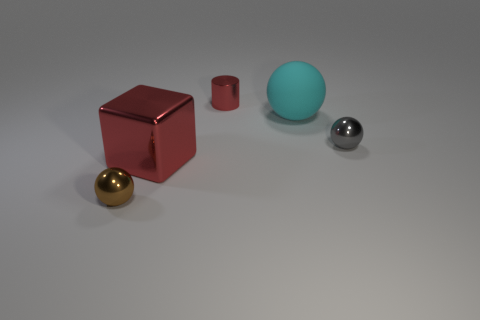Is there any other thing that has the same material as the large ball?
Provide a short and direct response. No. There is a small ball behind the small sphere that is in front of the gray shiny ball; what number of balls are in front of it?
Give a very brief answer. 1. What is the size of the cyan thing that is the same shape as the gray thing?
Keep it short and to the point. Large. Are there fewer small metallic spheres that are on the left side of the large ball than small metal things?
Make the answer very short. Yes. Does the cyan object have the same shape as the tiny red metal thing?
Your answer should be very brief. No. The other tiny object that is the same shape as the tiny gray metallic thing is what color?
Give a very brief answer. Brown. How many small metal cylinders are the same color as the big metal block?
Provide a succinct answer. 1. How many objects are either shiny balls that are on the right side of the small brown ball or tiny gray shiny balls?
Offer a terse response. 1. There is a red thing in front of the matte sphere; what size is it?
Give a very brief answer. Large. Are there fewer tiny red metallic objects than small blocks?
Your answer should be very brief. No. 